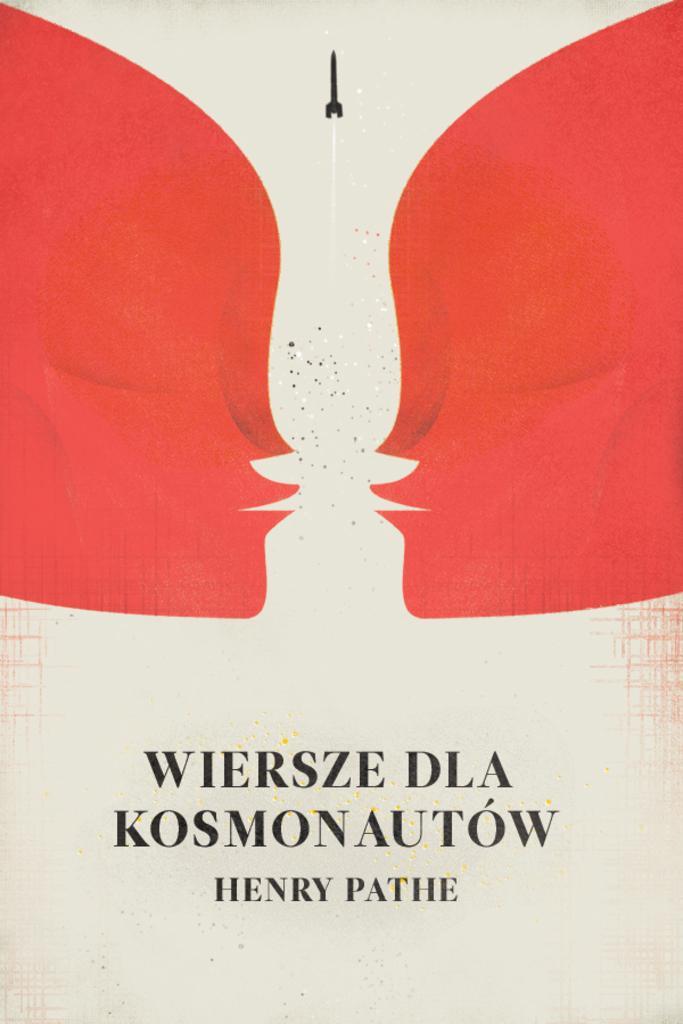Can you describe this image briefly? In this picture I can see there is a red color image on to left and right, there is some glitter in between and there is something at the bottom of the image. 